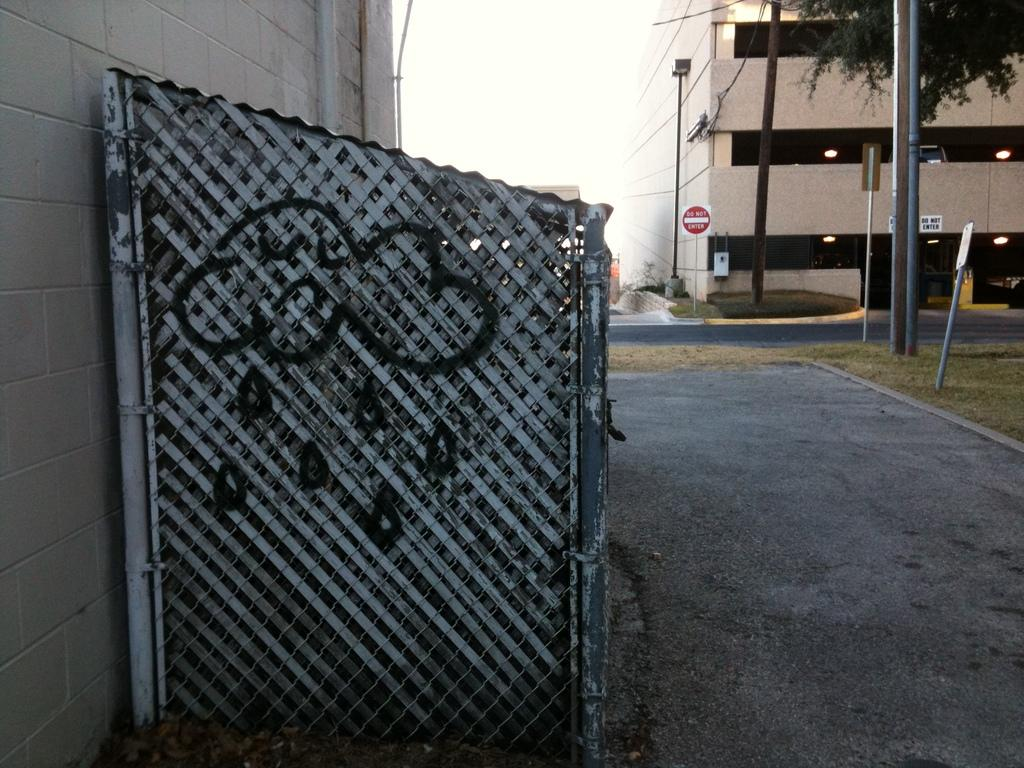What is located in the foreground of the image? There is a shed, grass, and buildings in the foreground of the image. What can be seen in the background of the image? There are sign boards, light poles, a tree, and the sky visible in the background of the image. What might suggest that the image was taken on a road? The presence of buildings, light poles, and sign boards in the image may suggest that it was taken on a road. What type of alarm can be heard going off in the image? There is no alarm present in the image, and therefore no sound can be heard. What type of table is visible in the image? There is no table present in the image. 